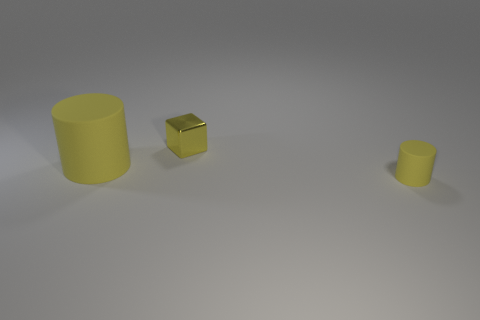Subtract all gray blocks. Subtract all brown spheres. How many blocks are left? 1 Add 2 small blocks. How many objects exist? 5 Subtract all cubes. How many objects are left? 2 Add 2 small yellow matte objects. How many small yellow matte objects are left? 3 Add 3 purple matte blocks. How many purple matte blocks exist? 3 Subtract 0 cyan blocks. How many objects are left? 3 Subtract all large matte objects. Subtract all tiny yellow rubber cylinders. How many objects are left? 1 